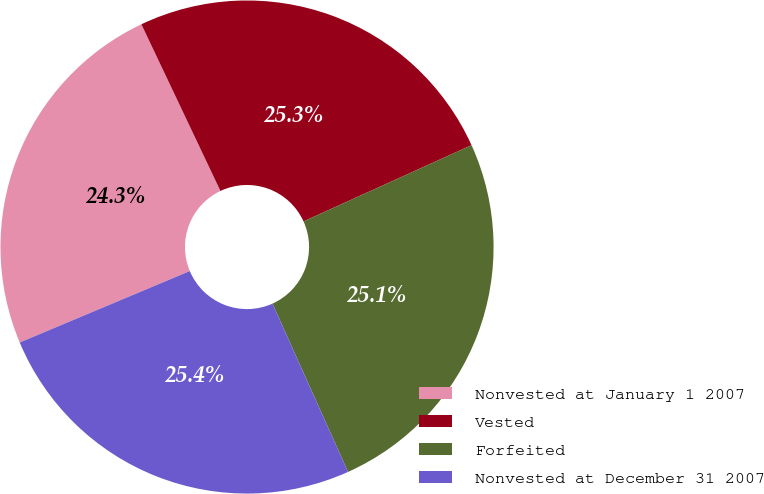<chart> <loc_0><loc_0><loc_500><loc_500><pie_chart><fcel>Nonvested at January 1 2007<fcel>Vested<fcel>Forfeited<fcel>Nonvested at December 31 2007<nl><fcel>24.28%<fcel>25.27%<fcel>25.06%<fcel>25.39%<nl></chart> 